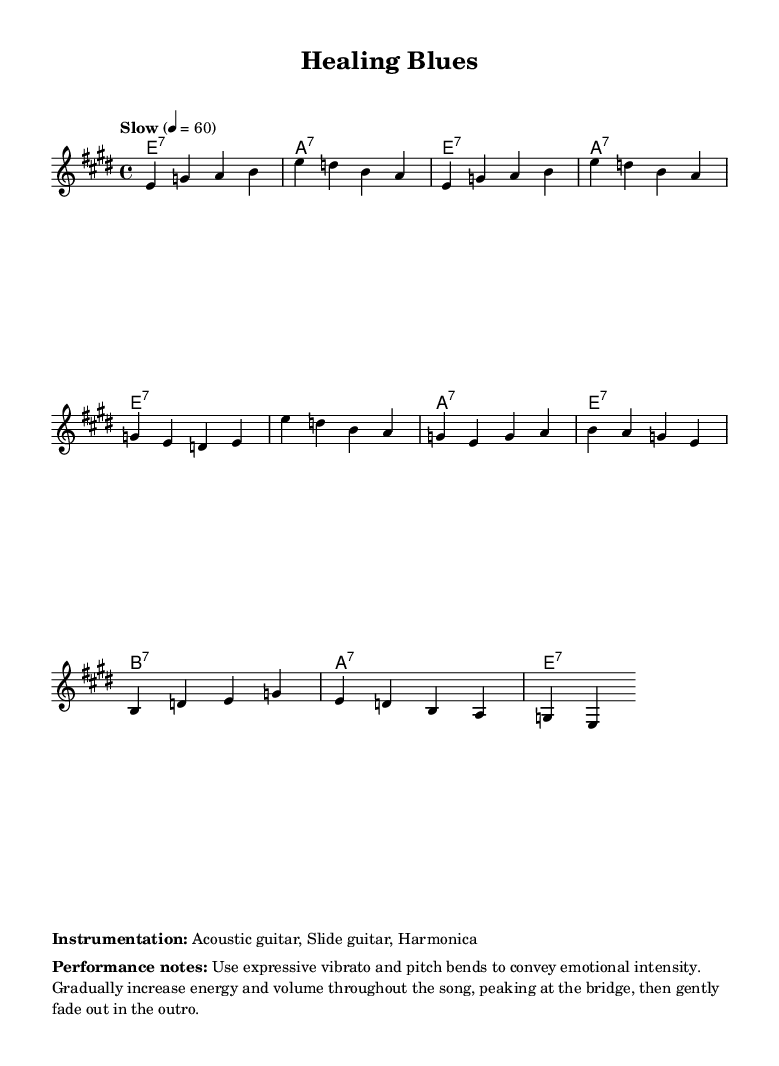What is the key signature of this music? The key signature is E major, which has four sharps (F#, C#, G#, and D#). It can be identified by the sharp symbols placed on the line and space of the staff at the beginning of the piece.
Answer: E major What is the time signature of this music? The time signature is 4/4, indicated by the two numbers at the beginning of the staff. The top number '4' signifies four beats per measure, and the lower '4' indicates that the quarter note receives one beat.
Answer: 4/4 What is the tempo marking of the piece? The tempo marking is "Slow" with a metronome mark of 60 beats per minute. This is noted in the tempo indication section at the beginning, which sets the pace for the piece.
Answer: Slow How many measures does the verse section contain? The verse section consists of four measures, as observed by the grouping of the notes within the musical staff. Each measure is separated by vertical bar lines, and the melody for the verse is defined within these four measures.
Answer: 4 What are the instrumental components used in this piece? The instrumentation includes acoustic guitar, slide guitar, and harmonica. This information is explicitly mentioned in the marked section under "Instrumentation" in the sheet music.
Answer: Acoustic guitar, Slide guitar, Harmonica Identify the emotional peak of the song and provide its position in the structure. The emotional peak occurs at the bridge, and this can be deduced from the performance notes that suggest increasing energy and volume leading up to the bridge, indicating heightened emotional intensity. The transition into this section is marked by a significant shift in dynamics.
Answer: Bridge What type of chord progression is primarily used in this blues piece? The chord progression is a typical delta blues progression, primarily comprising dominant seventh chords (E7, A7, and B7). This can be recognized from the harmonic structure in the chord mode section, which follows the common blues pattern.
Answer: Dominant seventh chords 